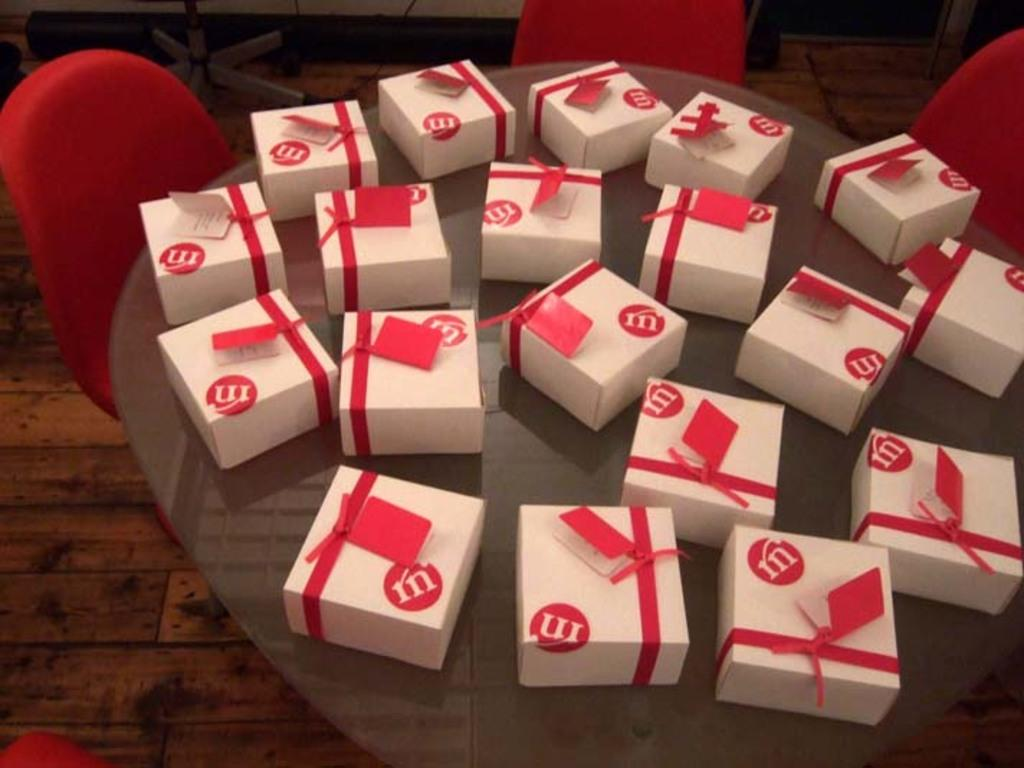Provide a one-sentence caption for the provided image. a bunch of white gifts with the word M on red. 